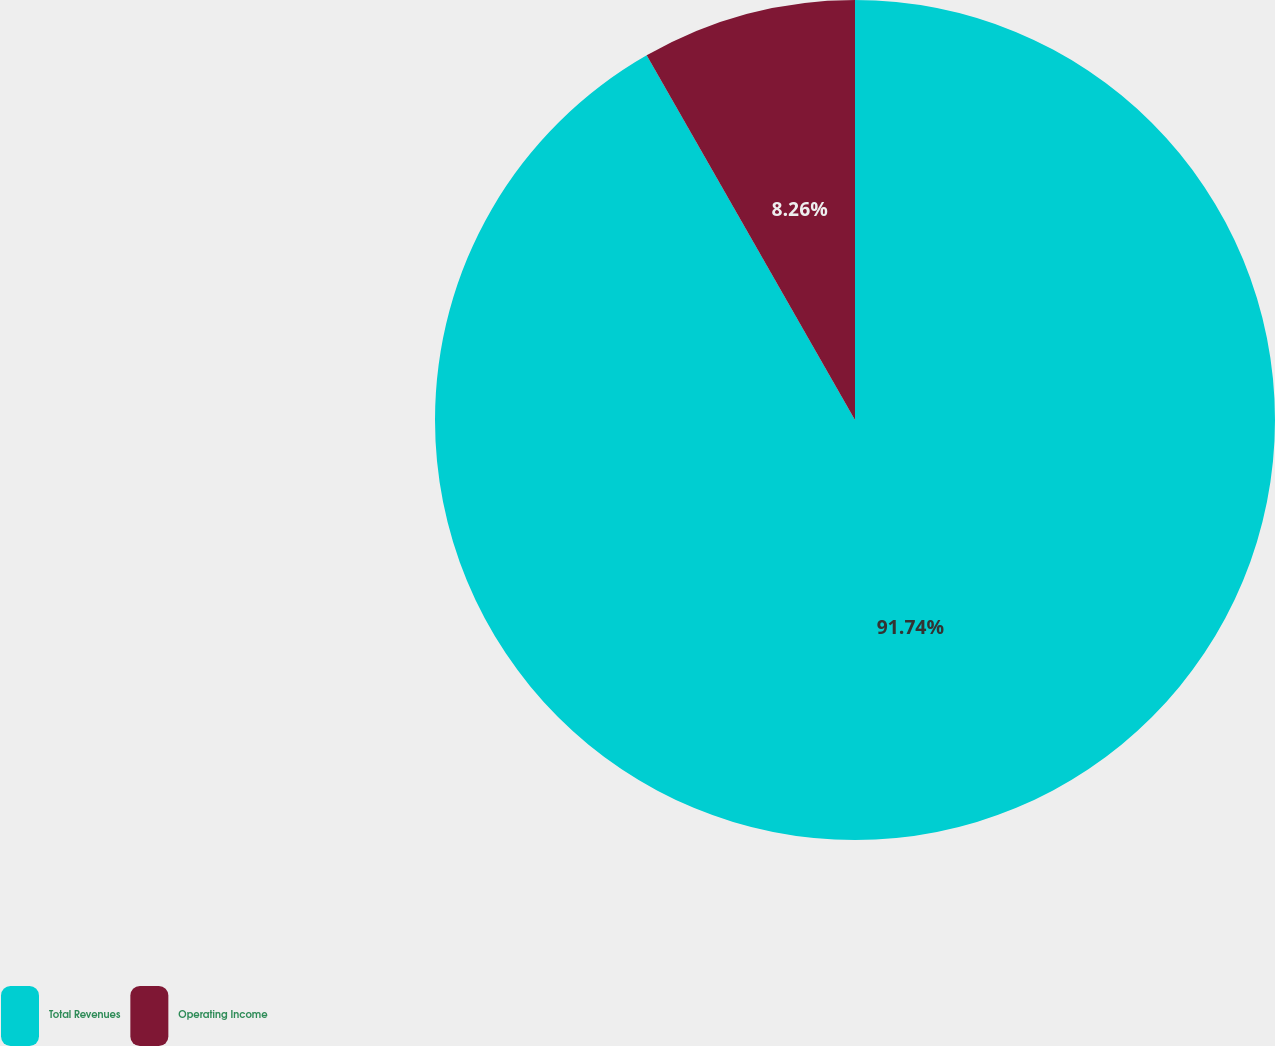<chart> <loc_0><loc_0><loc_500><loc_500><pie_chart><fcel>Total Revenues<fcel>Operating Income<nl><fcel>91.74%<fcel>8.26%<nl></chart> 